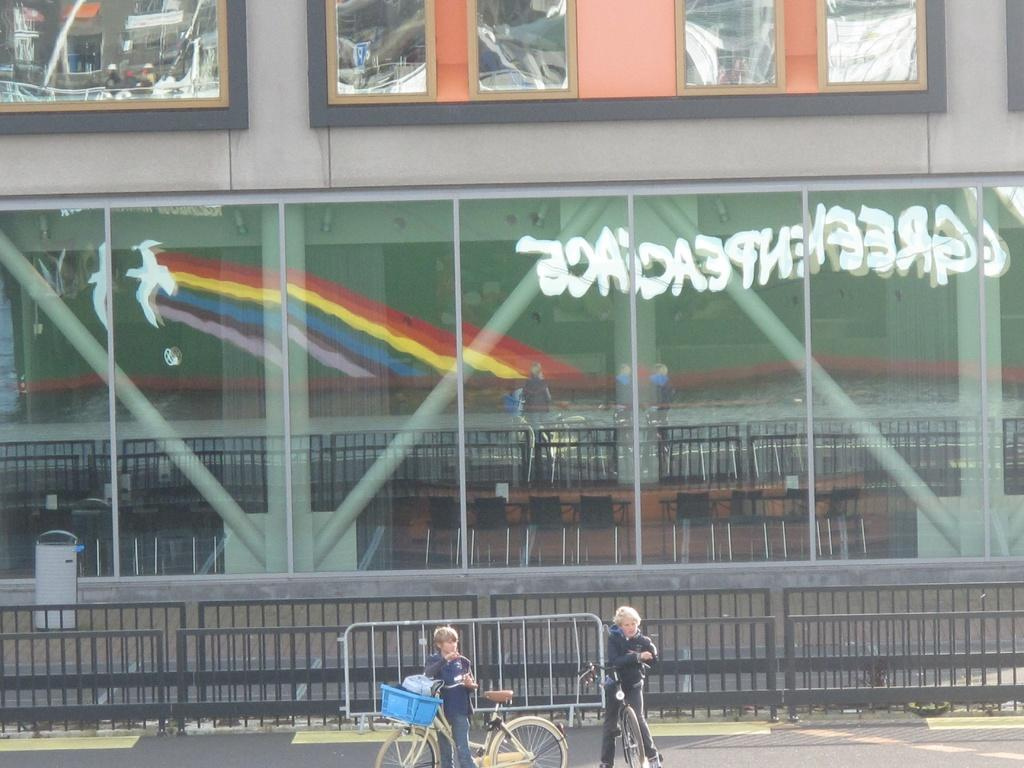<image>
Create a compact narrative representing the image presented. A reflection of the word "Greenpeace" can be seen in a building window. 